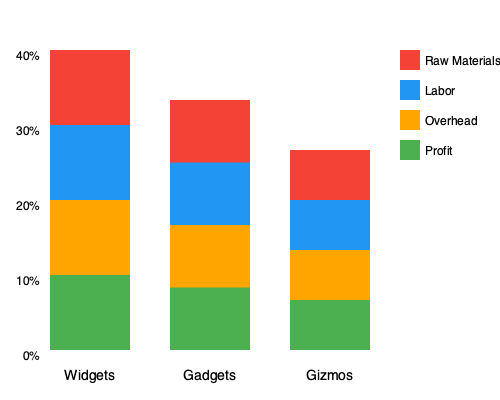Alright, let's cut through the fancy charts and get down to brass tacks. You've got three product lines: Widgets, Gadgets, and Gizmos. Each one's costs are broken down into raw materials, labor, and overhead, with what's left being profit. Which product is putting the most cash in your pocket, percentage-wise? And while we're at it, which one's eating up the most in raw materials? Let's break this down step-by-step, no fluff:

1) First, we need to identify the profit for each product. That's the green part at the top of each bar.

2) For Widgets:
   Profit is 25% of the total bar (1/4 of the bar)

3) For Gadgets:
   Profit is 25% of the total bar (1/4 of the bar)

4) For Gizmos:
   Profit is 25% of the total bar (1/4 of the bar)

5) Looks like they're all making the same percentage profit. No clear winner here.

6) Now, for raw materials, we're looking at the red part at the bottom of each bar.

7) For Widgets:
   Raw materials are 25% of the total bar (1/4 of the bar)

8) For Gadgets:
   Raw materials are 25% of the total bar (1/4 of the bar)

9) For Gizmos:
   Raw materials are 25% of the total bar (1/4 of the bar)

10) Again, they're all the same percentage for raw materials.

So, in terms of percentages, all products are equal for both profit and raw material costs. But remember, percentages don't tell the whole story. The actual dollar amounts could be quite different depending on the selling price of each product.
Answer: All products have equal profit percentages (25%) and raw material percentages (25%). 